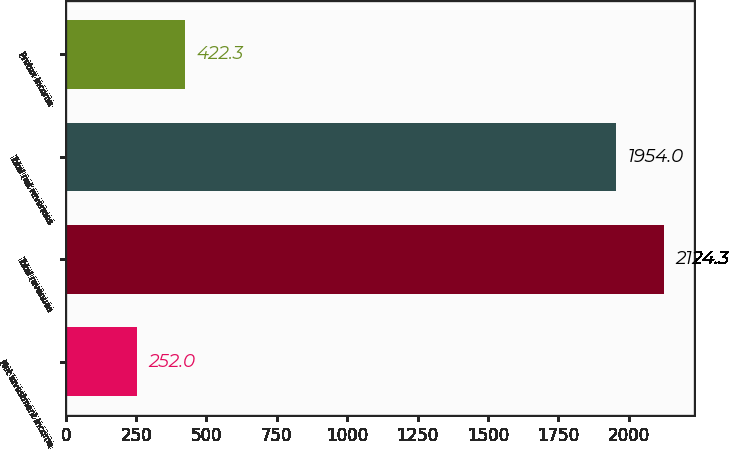<chart> <loc_0><loc_0><loc_500><loc_500><bar_chart><fcel>Net investment income<fcel>Total revenues<fcel>Total net revenues<fcel>Pretax income<nl><fcel>252<fcel>2124.3<fcel>1954<fcel>422.3<nl></chart> 